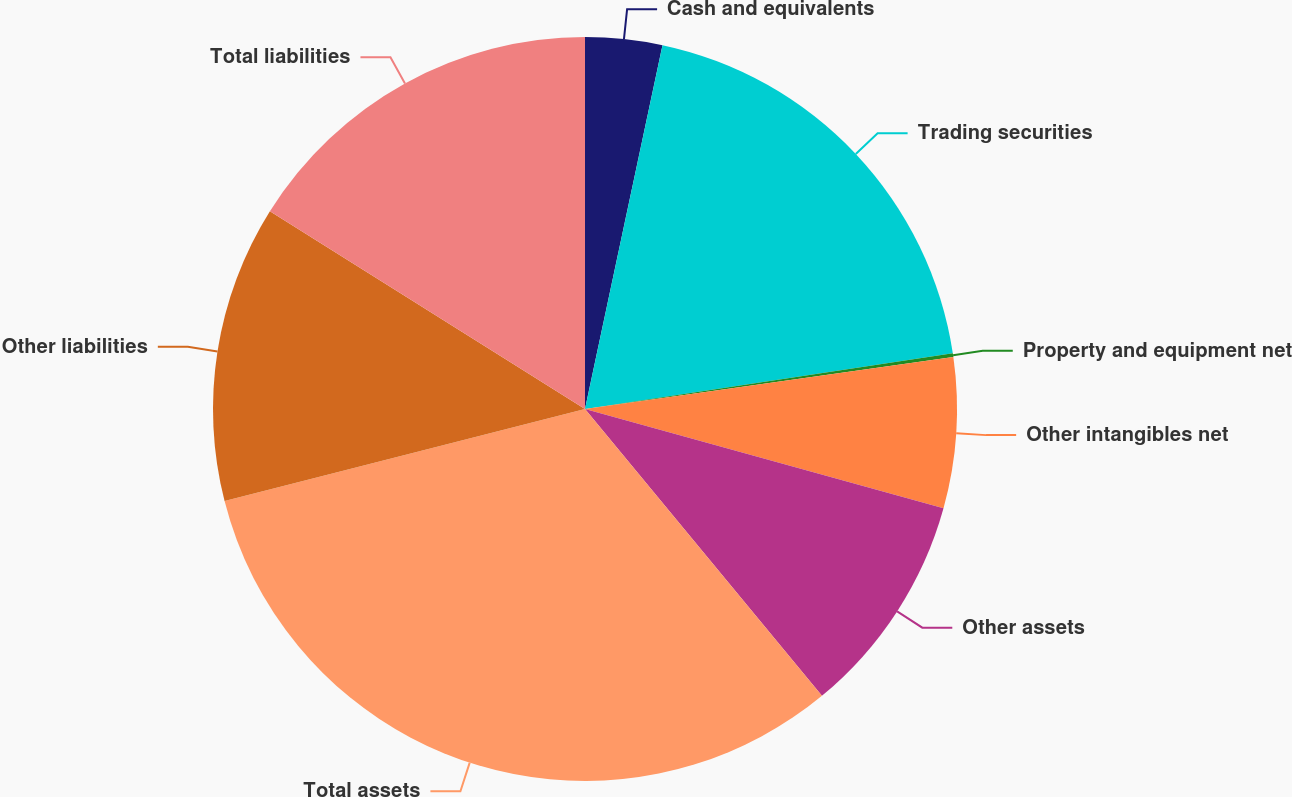Convert chart. <chart><loc_0><loc_0><loc_500><loc_500><pie_chart><fcel>Cash and equivalents<fcel>Trading securities<fcel>Property and equipment net<fcel>Other intangibles net<fcel>Other assets<fcel>Total assets<fcel>Other liabilities<fcel>Total liabilities<nl><fcel>3.34%<fcel>19.27%<fcel>0.16%<fcel>6.53%<fcel>9.71%<fcel>32.01%<fcel>12.9%<fcel>16.08%<nl></chart> 